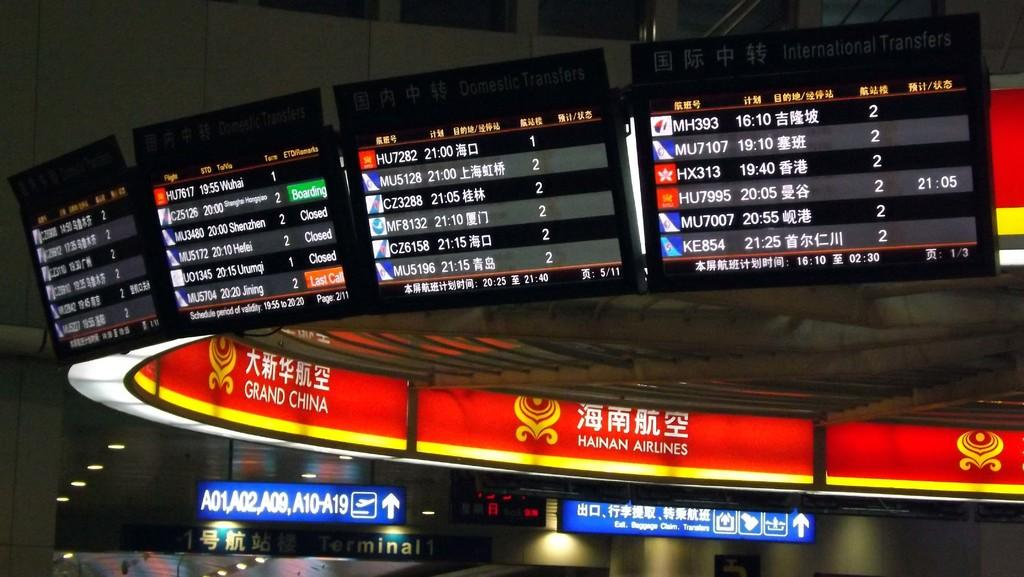<image>
Offer a succinct explanation of the picture presented. The inner ring of the digital display signs includes signs for Grand China and Hainan Airlines. 